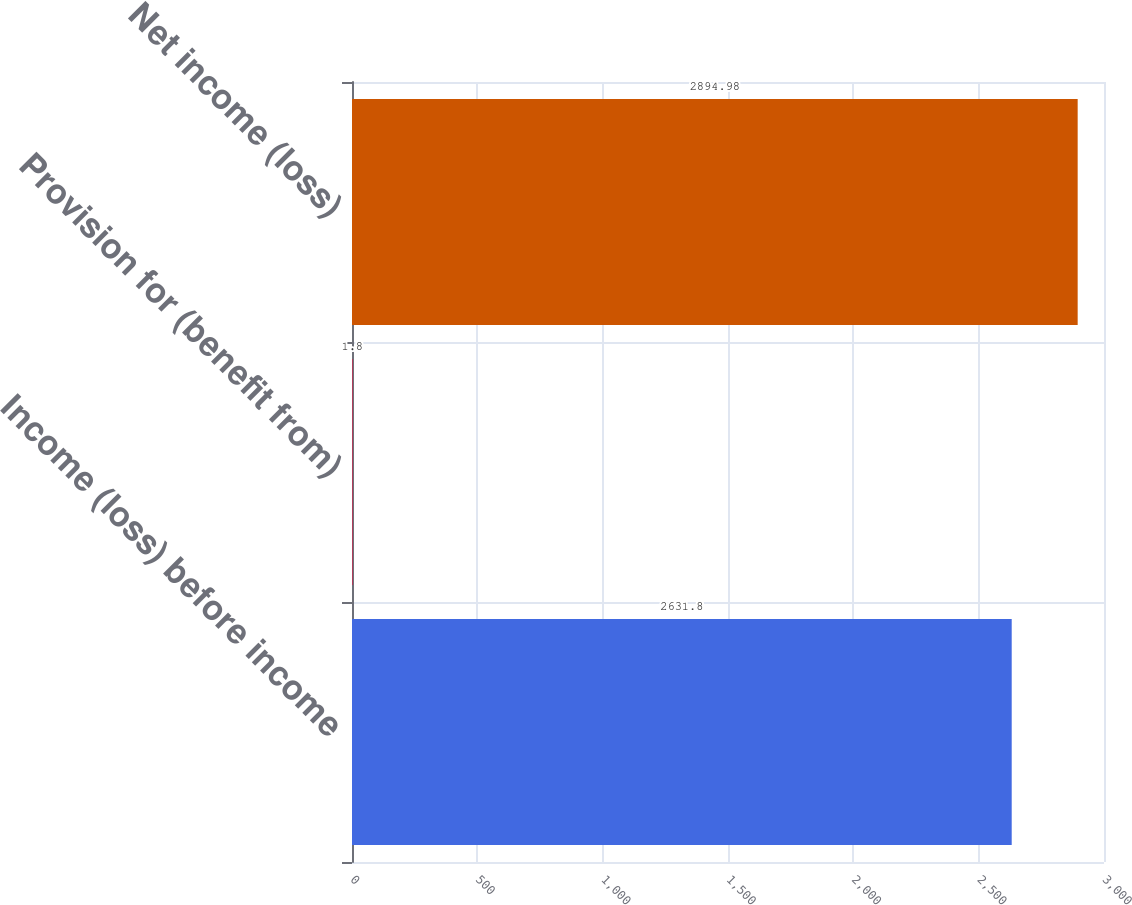<chart> <loc_0><loc_0><loc_500><loc_500><bar_chart><fcel>Income (loss) before income<fcel>Provision for (benefit from)<fcel>Net income (loss)<nl><fcel>2631.8<fcel>1.8<fcel>2894.98<nl></chart> 